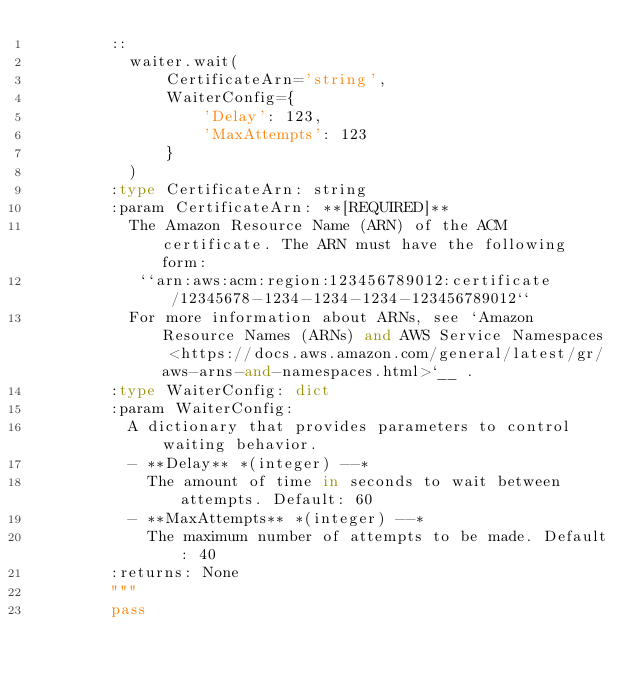<code> <loc_0><loc_0><loc_500><loc_500><_Python_>        ::
          waiter.wait(
              CertificateArn='string',
              WaiterConfig={
                  'Delay': 123,
                  'MaxAttempts': 123
              }
          )
        :type CertificateArn: string
        :param CertificateArn: **[REQUIRED]**
          The Amazon Resource Name (ARN) of the ACM certificate. The ARN must have the following form:
           ``arn:aws:acm:region:123456789012:certificate/12345678-1234-1234-1234-123456789012``
          For more information about ARNs, see `Amazon Resource Names (ARNs) and AWS Service Namespaces <https://docs.aws.amazon.com/general/latest/gr/aws-arns-and-namespaces.html>`__ .
        :type WaiterConfig: dict
        :param WaiterConfig:
          A dictionary that provides parameters to control waiting behavior.
          - **Delay** *(integer) --*
            The amount of time in seconds to wait between attempts. Default: 60
          - **MaxAttempts** *(integer) --*
            The maximum number of attempts to be made. Default: 40
        :returns: None
        """
        pass
</code> 